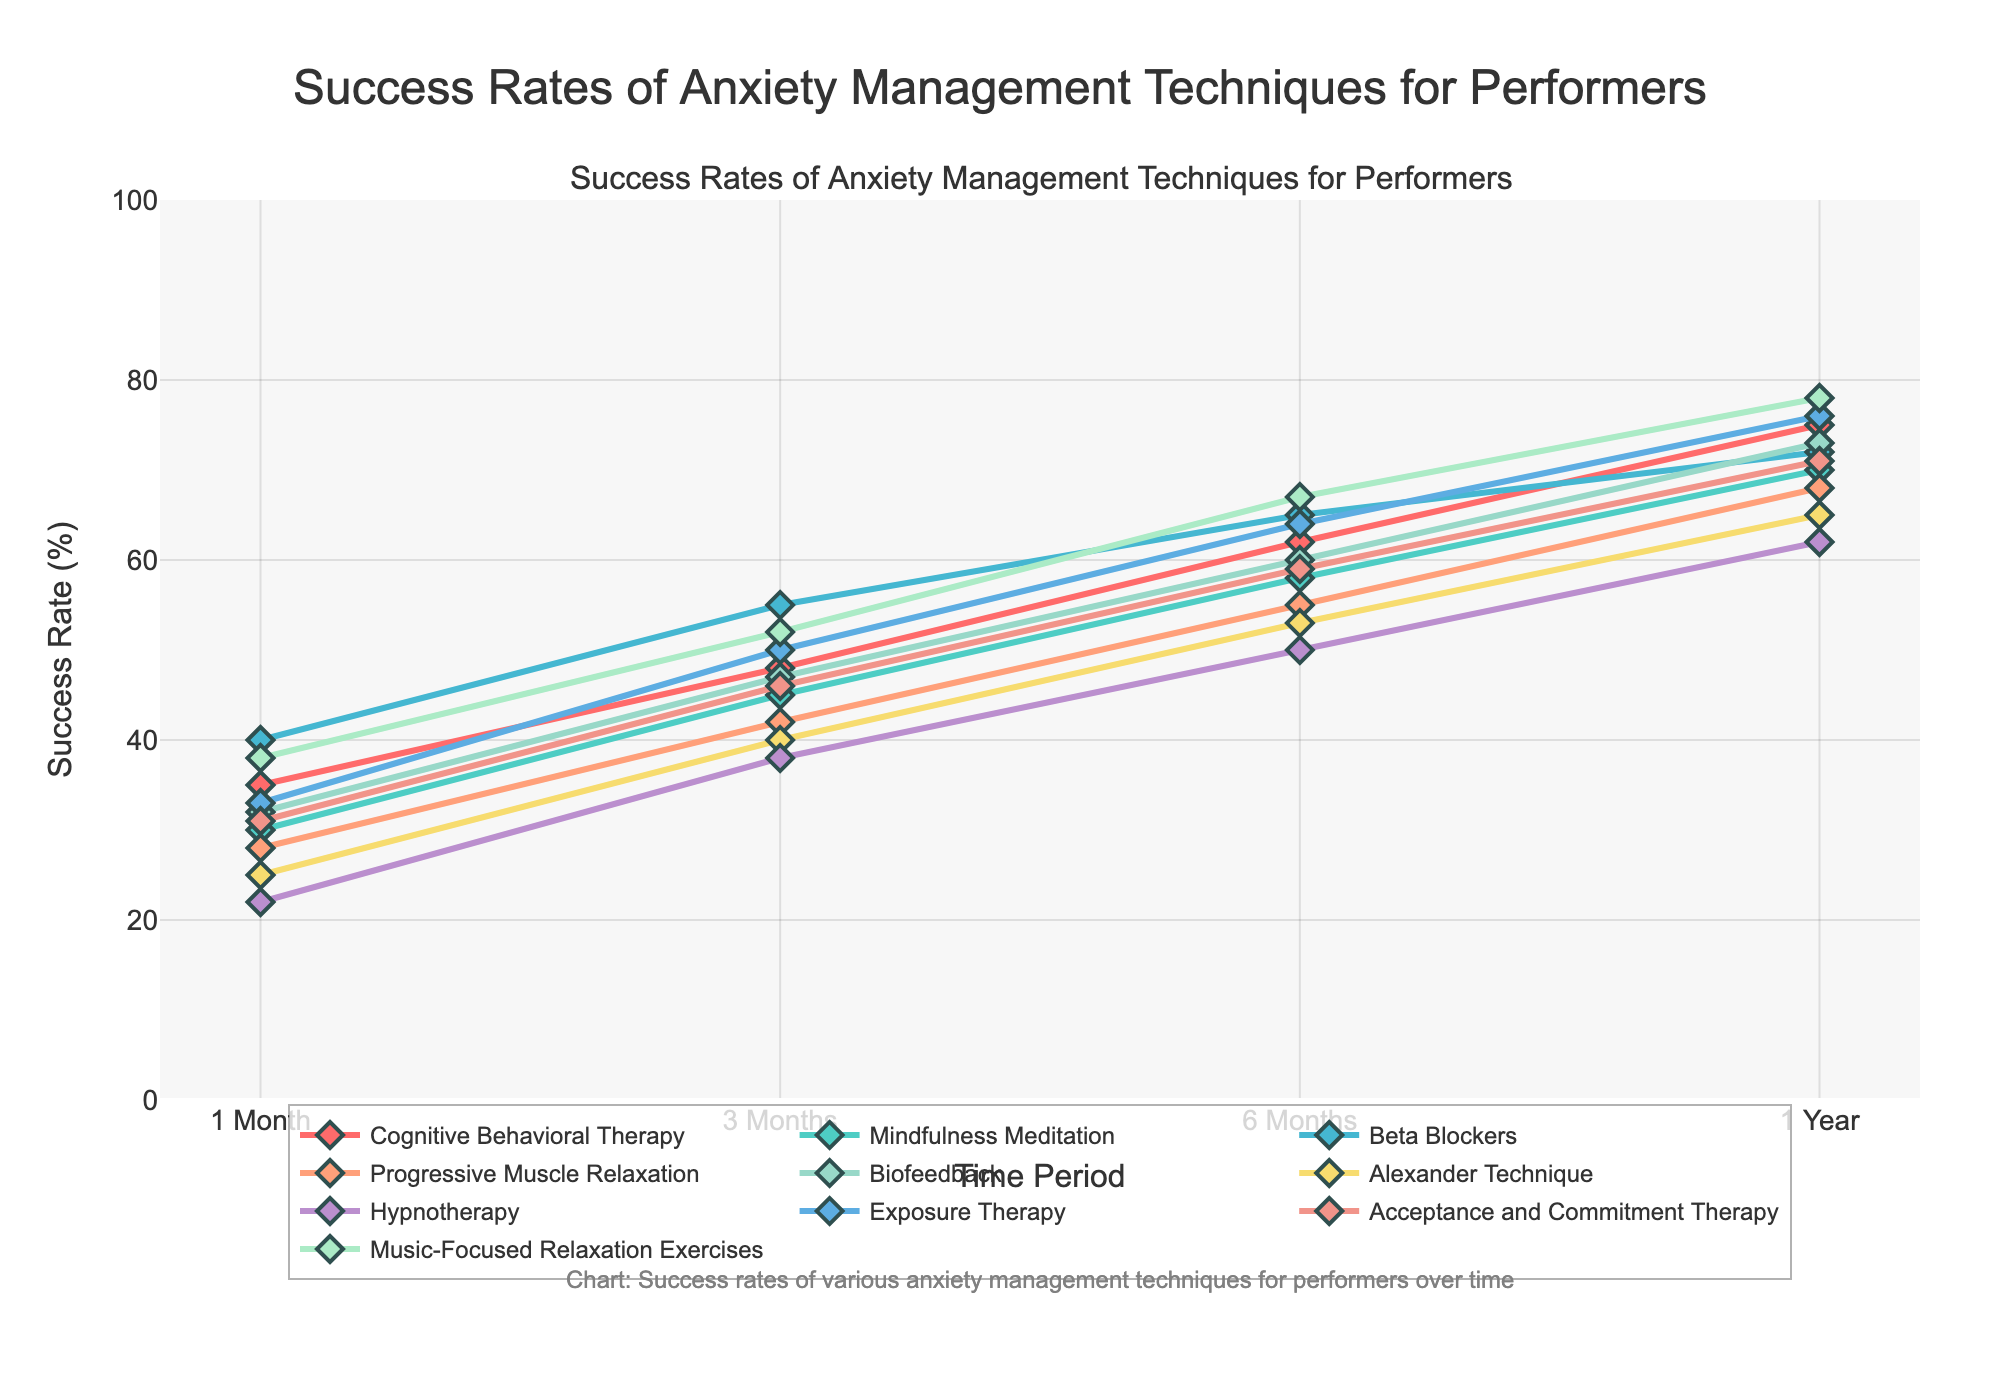What is the difference in success rate between Cognitive Behavioral Therapy and Beta Blockers at 6 months? To find the difference in success rate between Cognitive Behavioral Therapy and Beta Blockers at 6 months, we subtract the success rate of Beta Blockers from that of Cognitive Behavioral Therapy at the same time period. Cognitive Behavioral Therapy is at 62% and Beta Blockers are at 65%. So, 65% - 62% = -3%.
Answer: -3% Which technique has the highest success rate at 1 month, and what is that rate? To find the technique with the highest success rate at 1 month, we compare the success rates of all techniques at that time. Music-Focused Relaxation Exercises has the highest rate at 38%.
Answer: Music-Focused Relaxation Exercises, 38% What is the average success rate of Mindfulness Meditation over all time periods? To find the average success rate of Mindfulness Meditation over all time periods, we sum up the success rates at 1 Month, 3 Months, 6 Months, and 1 Year, and then divide by the number of periods. The rates are 30%, 45%, 58%, and 70%. So, (30+45+58+70)/4 = 203/4 = 50.75%.
Answer: 50.75% At 1 year, how many techniques have a success rate above 70%? To find out how many techniques have a success rate above 70% at 1 year, look at each technique's success rate at that time. Cognitive Behavioral Therapy (75%), Exposure Therapy (76%), and Music-Focused Relaxation Exercises (78%) each have success rates above 70%. So, there are 3 techniques.
Answer: 3 Which technique showed the greatest improvement in success rate from 1 month to 1 year? To find the technique with the greatest improvement in success rate from 1 month to 1 year, we subtract the 1-month success rate from the 1-year success rate for each technique and find the maximum difference. The differences are as follows: Cognitive Behavioral Therapy (75-35=40), Mindfulness Meditation (70-30=40), Beta Blockers (72-40=32), Progressive Muscle Relaxation (68-28=40), Biofeedback (73-32=41), Alexander Technique (65-25=40), Hypnotherapy (62-22=40), Exposure Therapy (76-33=43), Acceptance and Commitment Therapy (71-31=40), Music-Focused Relaxation Exercises (78-38=40). The greatest improvement is seen with Exposure Therapy, which improved by 43%.
Answer: Exposure Therapy, 43% What is the combined success rate of Biofeedback and Progressive Muscle Relaxation at 3 months? To find the combined success rate of Biofeedback and Progressive Muscle Relaxation at 3 months, we add their individual success rates at that time. Biofeedback is at 47%, and Progressive Muscle Relaxation is at 42%. So, 47% + 42% = 89%.
Answer: 89% At 1 year, which technique has a higher success rate: Hypnotherapy or Alexander Technique? To determine which technique has a higher success rate at 1 year between Hypnotherapy and Alexander Technique, compare their success rates at that time. Hypnotherapy is at 62%, and Alexander Technique is at 65%. Therefore, Alexander Technique has a higher success rate.
Answer: Alexander Technique How many techniques have a success rate of 60% and above at 6 months? To determine how many techniques have a success rate of 60% and above at 6 months, identify the techniques that meet this criterion. Cognitive Behavioral Therapy (62%), Beta Blockers (65%), Biofeedback (60%), Exposure Therapy (64%), and Music-Focused Relaxation Exercises (67%) meet this criterion. There are 5 such techniques.
Answer: 5 